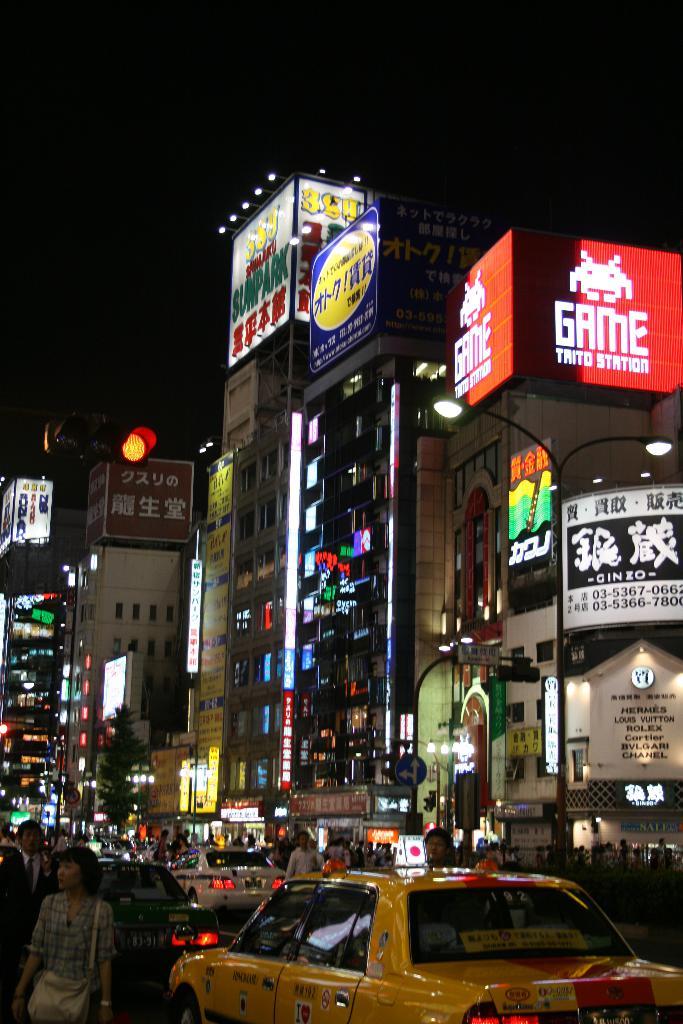What kind of station is on the red sign?
Offer a terse response. Game. 